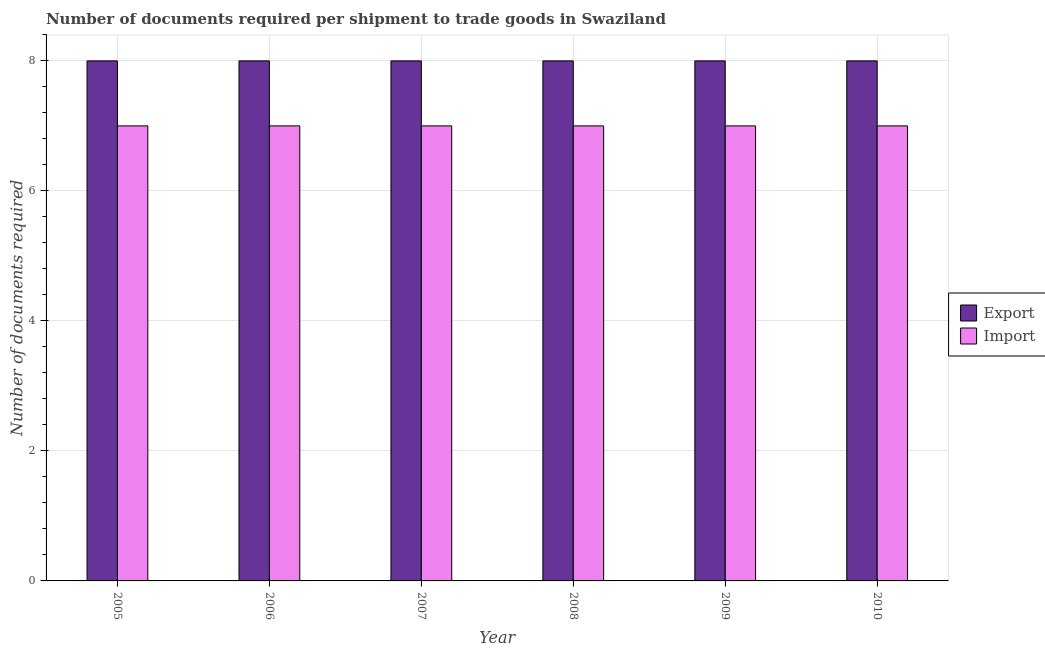How many different coloured bars are there?
Make the answer very short. 2. Are the number of bars per tick equal to the number of legend labels?
Keep it short and to the point. Yes. Are the number of bars on each tick of the X-axis equal?
Offer a very short reply. Yes. What is the label of the 4th group of bars from the left?
Keep it short and to the point. 2008. What is the number of documents required to import goods in 2005?
Keep it short and to the point. 7. Across all years, what is the maximum number of documents required to import goods?
Offer a very short reply. 7. Across all years, what is the minimum number of documents required to import goods?
Ensure brevity in your answer.  7. In which year was the number of documents required to export goods maximum?
Your answer should be very brief. 2005. In which year was the number of documents required to export goods minimum?
Your response must be concise. 2005. What is the total number of documents required to export goods in the graph?
Provide a succinct answer. 48. What is the difference between the number of documents required to export goods in 2007 and that in 2010?
Offer a very short reply. 0. What is the difference between the number of documents required to import goods in 2009 and the number of documents required to export goods in 2007?
Offer a very short reply. 0. In the year 2005, what is the difference between the number of documents required to export goods and number of documents required to import goods?
Keep it short and to the point. 0. In how many years, is the number of documents required to import goods greater than 6.4?
Offer a terse response. 6. What is the ratio of the number of documents required to import goods in 2006 to that in 2008?
Your response must be concise. 1. Is the number of documents required to export goods in 2005 less than that in 2010?
Offer a very short reply. No. In how many years, is the number of documents required to export goods greater than the average number of documents required to export goods taken over all years?
Your answer should be very brief. 0. What does the 1st bar from the left in 2009 represents?
Keep it short and to the point. Export. What does the 2nd bar from the right in 2006 represents?
Provide a short and direct response. Export. Are all the bars in the graph horizontal?
Provide a succinct answer. No. Does the graph contain any zero values?
Keep it short and to the point. No. Does the graph contain grids?
Keep it short and to the point. Yes. Where does the legend appear in the graph?
Give a very brief answer. Center right. What is the title of the graph?
Make the answer very short. Number of documents required per shipment to trade goods in Swaziland. What is the label or title of the X-axis?
Give a very brief answer. Year. What is the label or title of the Y-axis?
Offer a very short reply. Number of documents required. What is the Number of documents required of Export in 2005?
Provide a succinct answer. 8. What is the Number of documents required in Export in 2006?
Offer a very short reply. 8. What is the Number of documents required of Export in 2007?
Your answer should be very brief. 8. What is the Number of documents required of Export in 2009?
Provide a succinct answer. 8. What is the Number of documents required in Import in 2009?
Keep it short and to the point. 7. Across all years, what is the maximum Number of documents required in Export?
Your response must be concise. 8. Across all years, what is the maximum Number of documents required in Import?
Make the answer very short. 7. Across all years, what is the minimum Number of documents required of Export?
Make the answer very short. 8. What is the difference between the Number of documents required in Export in 2005 and that in 2006?
Your answer should be compact. 0. What is the difference between the Number of documents required in Export in 2005 and that in 2009?
Offer a terse response. 0. What is the difference between the Number of documents required of Import in 2005 and that in 2009?
Give a very brief answer. 0. What is the difference between the Number of documents required of Import in 2005 and that in 2010?
Your answer should be very brief. 0. What is the difference between the Number of documents required of Import in 2006 and that in 2007?
Your answer should be compact. 0. What is the difference between the Number of documents required of Export in 2006 and that in 2008?
Offer a terse response. 0. What is the difference between the Number of documents required in Import in 2006 and that in 2008?
Give a very brief answer. 0. What is the difference between the Number of documents required in Export in 2006 and that in 2009?
Provide a succinct answer. 0. What is the difference between the Number of documents required in Import in 2007 and that in 2008?
Your answer should be compact. 0. What is the difference between the Number of documents required of Export in 2007 and that in 2009?
Make the answer very short. 0. What is the difference between the Number of documents required in Import in 2007 and that in 2009?
Make the answer very short. 0. What is the difference between the Number of documents required in Import in 2007 and that in 2010?
Offer a very short reply. 0. What is the difference between the Number of documents required in Import in 2008 and that in 2009?
Provide a succinct answer. 0. What is the difference between the Number of documents required of Export in 2008 and that in 2010?
Give a very brief answer. 0. What is the difference between the Number of documents required of Import in 2008 and that in 2010?
Provide a succinct answer. 0. What is the difference between the Number of documents required in Export in 2009 and that in 2010?
Provide a short and direct response. 0. What is the difference between the Number of documents required of Export in 2005 and the Number of documents required of Import in 2006?
Offer a terse response. 1. What is the difference between the Number of documents required of Export in 2005 and the Number of documents required of Import in 2007?
Your response must be concise. 1. What is the difference between the Number of documents required in Export in 2005 and the Number of documents required in Import in 2008?
Provide a succinct answer. 1. What is the difference between the Number of documents required in Export in 2006 and the Number of documents required in Import in 2009?
Make the answer very short. 1. What is the difference between the Number of documents required in Export in 2006 and the Number of documents required in Import in 2010?
Offer a very short reply. 1. What is the difference between the Number of documents required in Export in 2007 and the Number of documents required in Import in 2009?
Your answer should be very brief. 1. What is the difference between the Number of documents required of Export in 2007 and the Number of documents required of Import in 2010?
Offer a very short reply. 1. What is the difference between the Number of documents required in Export in 2009 and the Number of documents required in Import in 2010?
Your answer should be compact. 1. What is the average Number of documents required in Import per year?
Offer a terse response. 7. In the year 2008, what is the difference between the Number of documents required of Export and Number of documents required of Import?
Give a very brief answer. 1. In the year 2010, what is the difference between the Number of documents required in Export and Number of documents required in Import?
Keep it short and to the point. 1. What is the ratio of the Number of documents required in Export in 2005 to that in 2006?
Your answer should be compact. 1. What is the ratio of the Number of documents required of Export in 2005 to that in 2007?
Offer a very short reply. 1. What is the ratio of the Number of documents required of Import in 2005 to that in 2009?
Keep it short and to the point. 1. What is the ratio of the Number of documents required in Export in 2005 to that in 2010?
Ensure brevity in your answer.  1. What is the ratio of the Number of documents required in Export in 2006 to that in 2007?
Offer a very short reply. 1. What is the ratio of the Number of documents required of Export in 2006 to that in 2008?
Make the answer very short. 1. What is the ratio of the Number of documents required in Import in 2006 to that in 2008?
Give a very brief answer. 1. What is the ratio of the Number of documents required of Export in 2006 to that in 2009?
Make the answer very short. 1. What is the ratio of the Number of documents required in Export in 2006 to that in 2010?
Ensure brevity in your answer.  1. What is the ratio of the Number of documents required of Import in 2006 to that in 2010?
Your answer should be very brief. 1. What is the ratio of the Number of documents required in Export in 2007 to that in 2008?
Offer a terse response. 1. What is the ratio of the Number of documents required in Import in 2007 to that in 2009?
Keep it short and to the point. 1. What is the ratio of the Number of documents required of Export in 2007 to that in 2010?
Ensure brevity in your answer.  1. What is the ratio of the Number of documents required in Export in 2008 to that in 2009?
Your response must be concise. 1. What is the ratio of the Number of documents required in Import in 2008 to that in 2009?
Provide a succinct answer. 1. What is the ratio of the Number of documents required in Export in 2008 to that in 2010?
Provide a succinct answer. 1. What is the ratio of the Number of documents required in Export in 2009 to that in 2010?
Ensure brevity in your answer.  1. What is the difference between the highest and the second highest Number of documents required in Export?
Your answer should be very brief. 0. What is the difference between the highest and the lowest Number of documents required of Export?
Your answer should be compact. 0. What is the difference between the highest and the lowest Number of documents required of Import?
Keep it short and to the point. 0. 